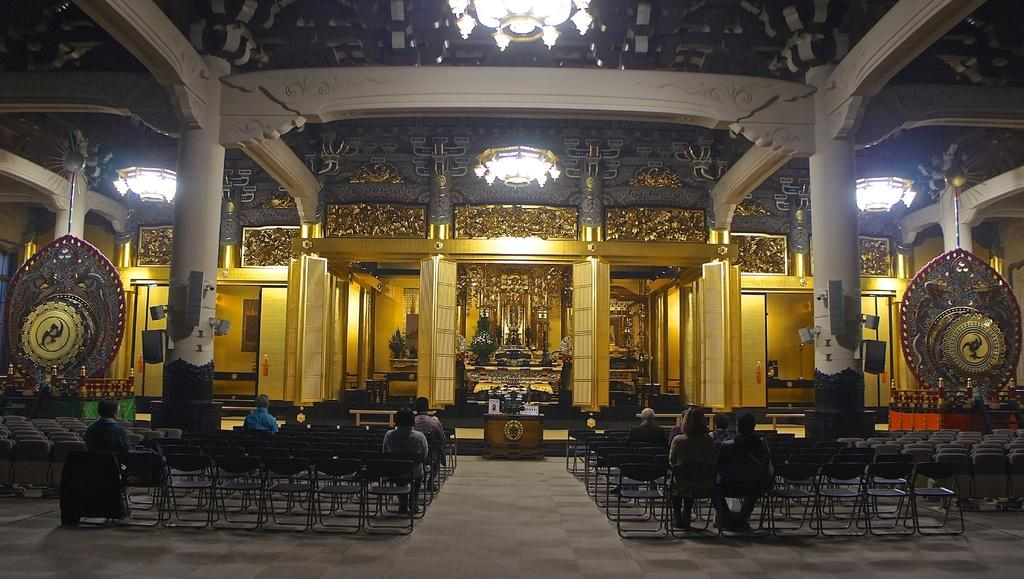What are the people in the image doing? The people in the image are sitting on chairs. What can be seen in the background of the image? There is a building in the image. How many chandeliers are visible in the image? There are three chandeliers visible in the image. What type of lip can be seen on the canvas in the image? There is no lip or canvas present in the image. 